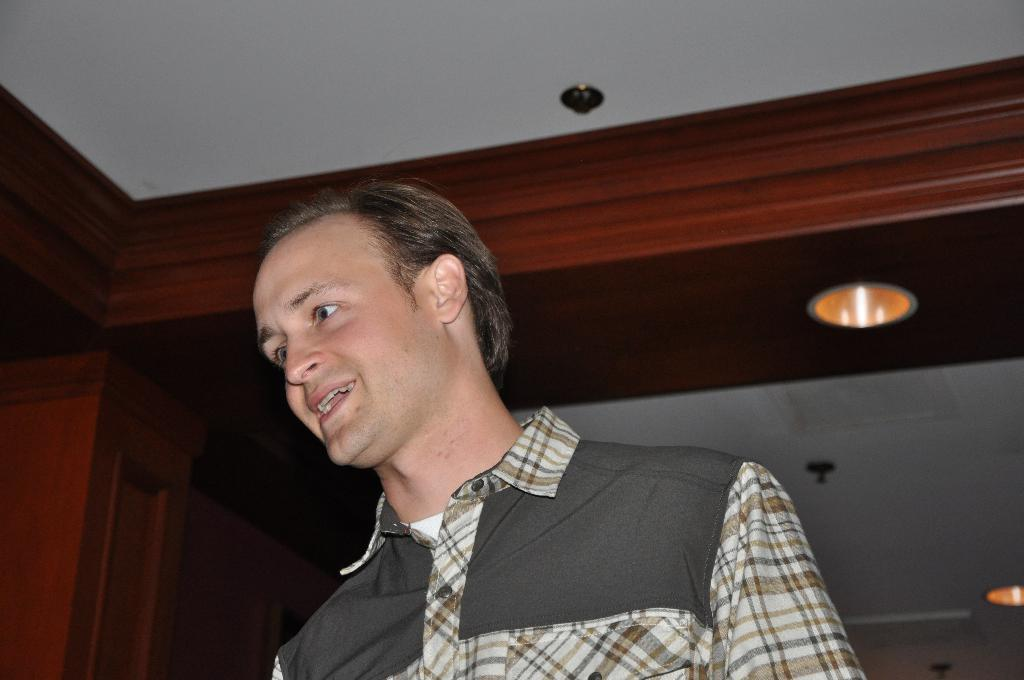Who or what is present in the image? There is a person in the image. What part of a room can be seen in the image? There is a ceiling visible in the image. How many jellyfish are swimming in the image? There are no jellyfish present in the image. What type of milk is being used by the person in the image? There is no milk or any indication of its use in the image. 